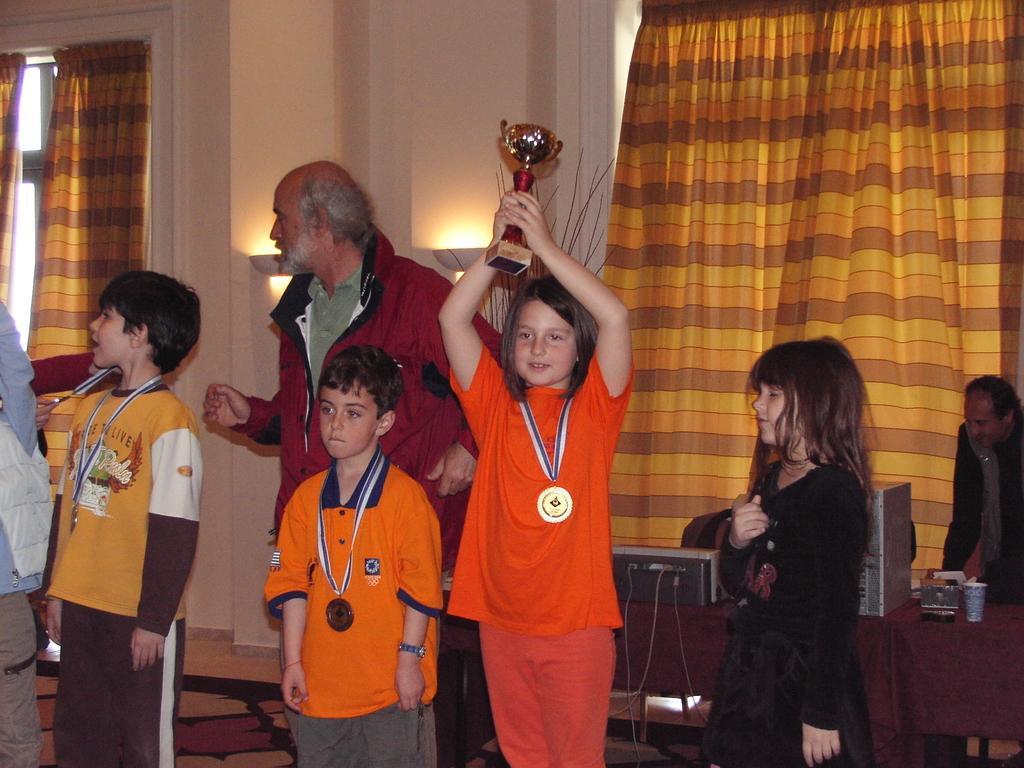Describe this image in one or two sentences. 3 children are standing wearing medal. A girl is holding a trophy. There are other people at the back. There is a table at the back. There are windows and curtains at the back. 